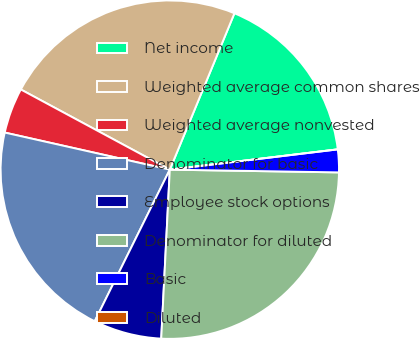<chart> <loc_0><loc_0><loc_500><loc_500><pie_chart><fcel>Net income<fcel>Weighted average common shares<fcel>Weighted average nonvested<fcel>Denominator for basic<fcel>Employee stock options<fcel>Denominator for diluted<fcel>Basic<fcel>Diluted<nl><fcel>16.85%<fcel>23.38%<fcel>4.34%<fcel>21.2%<fcel>6.51%<fcel>25.55%<fcel>2.17%<fcel>0.0%<nl></chart> 